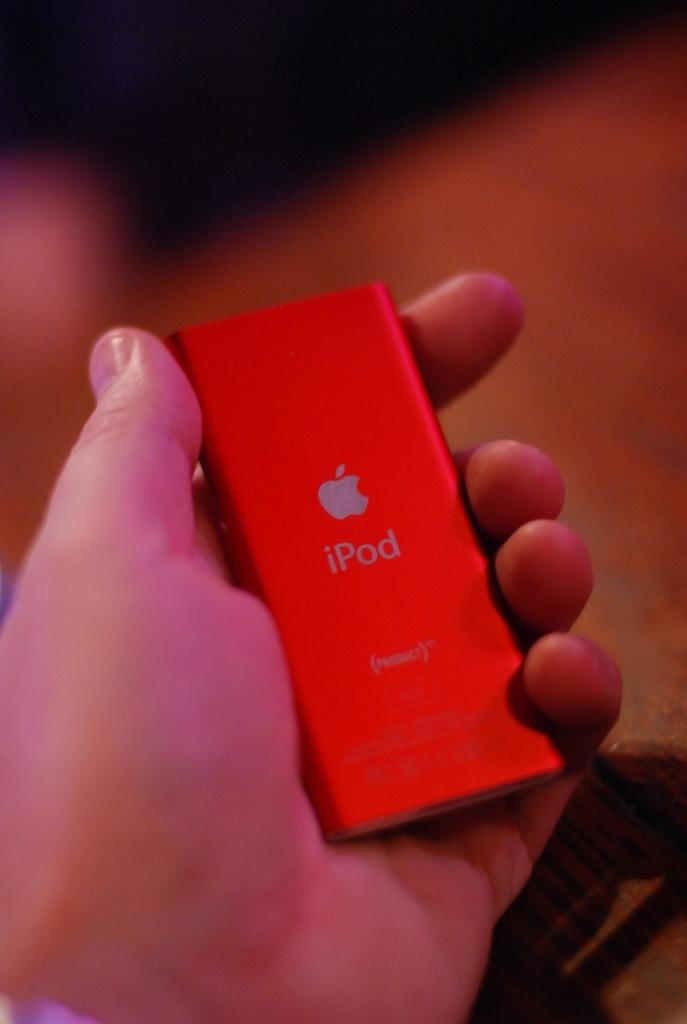<image>
Give a short and clear explanation of the subsequent image. Someone holding a small red iPod in their hand. 